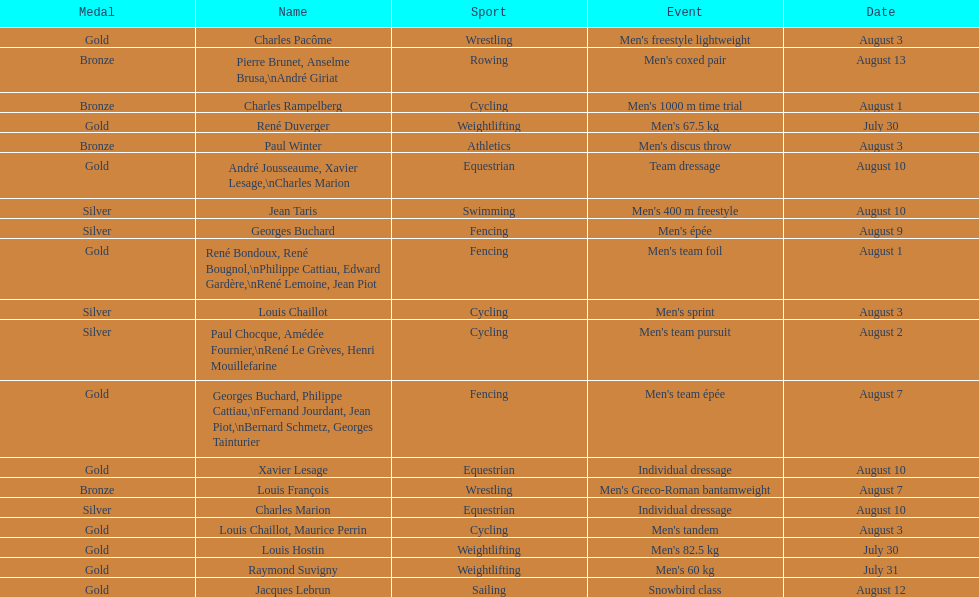What sport did louis challiot win the same medal as paul chocque in? Cycling. 